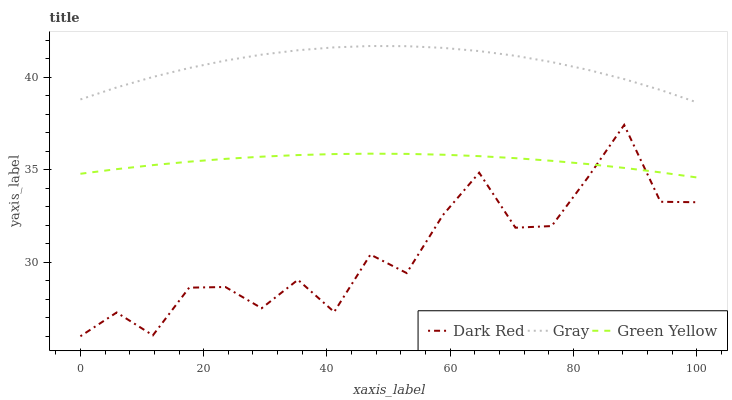Does Dark Red have the minimum area under the curve?
Answer yes or no. Yes. Does Gray have the maximum area under the curve?
Answer yes or no. Yes. Does Green Yellow have the minimum area under the curve?
Answer yes or no. No. Does Green Yellow have the maximum area under the curve?
Answer yes or no. No. Is Green Yellow the smoothest?
Answer yes or no. Yes. Is Dark Red the roughest?
Answer yes or no. Yes. Is Gray the smoothest?
Answer yes or no. No. Is Gray the roughest?
Answer yes or no. No. Does Dark Red have the lowest value?
Answer yes or no. Yes. Does Green Yellow have the lowest value?
Answer yes or no. No. Does Gray have the highest value?
Answer yes or no. Yes. Does Green Yellow have the highest value?
Answer yes or no. No. Is Green Yellow less than Gray?
Answer yes or no. Yes. Is Gray greater than Green Yellow?
Answer yes or no. Yes. Does Dark Red intersect Green Yellow?
Answer yes or no. Yes. Is Dark Red less than Green Yellow?
Answer yes or no. No. Is Dark Red greater than Green Yellow?
Answer yes or no. No. Does Green Yellow intersect Gray?
Answer yes or no. No. 